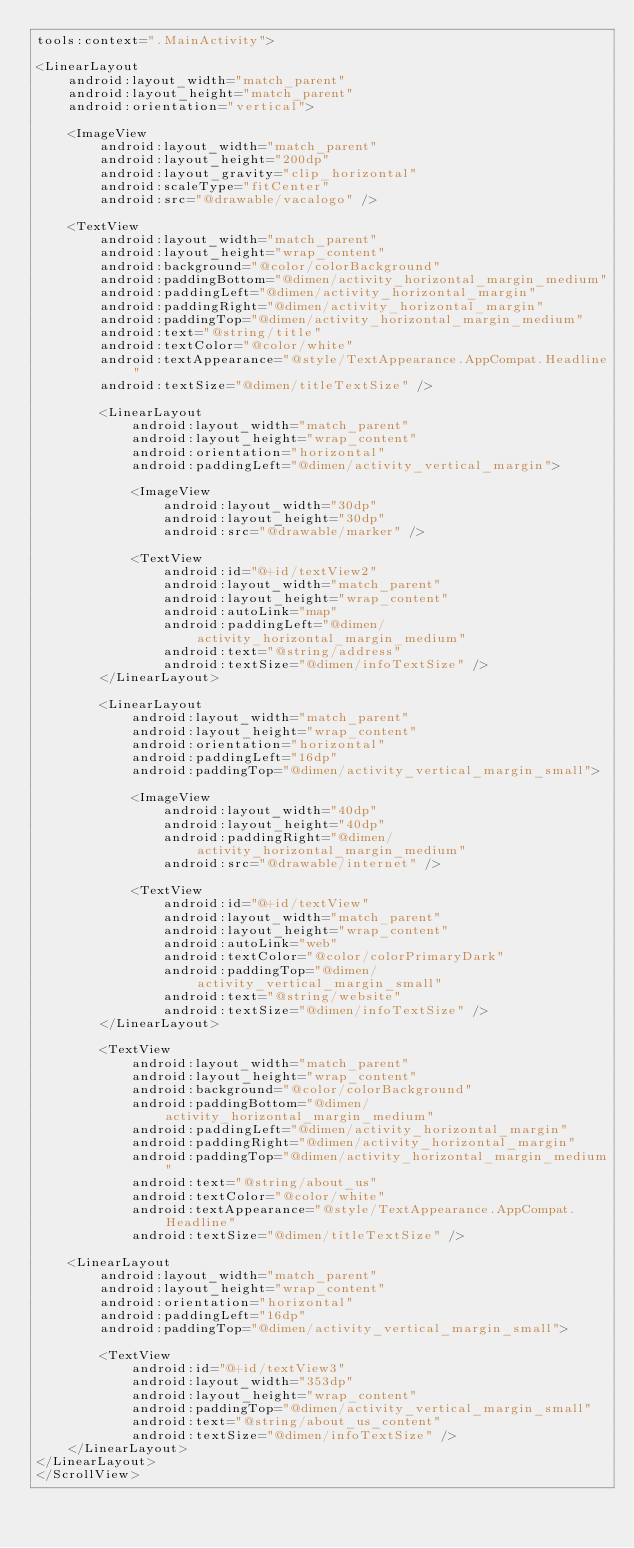<code> <loc_0><loc_0><loc_500><loc_500><_XML_>tools:context=".MainActivity">

<LinearLayout
    android:layout_width="match_parent"
    android:layout_height="match_parent"
    android:orientation="vertical">

    <ImageView
        android:layout_width="match_parent"
        android:layout_height="200dp"
        android:layout_gravity="clip_horizontal"
        android:scaleType="fitCenter"
        android:src="@drawable/vacalogo" />

    <TextView
        android:layout_width="match_parent"
        android:layout_height="wrap_content"
        android:background="@color/colorBackground"
        android:paddingBottom="@dimen/activity_horizontal_margin_medium"
        android:paddingLeft="@dimen/activity_horizontal_margin"
        android:paddingRight="@dimen/activity_horizontal_margin"
        android:paddingTop="@dimen/activity_horizontal_margin_medium"
        android:text="@string/title"
        android:textColor="@color/white"
        android:textAppearance="@style/TextAppearance.AppCompat.Headline"
        android:textSize="@dimen/titleTextSize" />

        <LinearLayout
            android:layout_width="match_parent"
            android:layout_height="wrap_content"
            android:orientation="horizontal"
            android:paddingLeft="@dimen/activity_vertical_margin">

            <ImageView
                android:layout_width="30dp"
                android:layout_height="30dp"
                android:src="@drawable/marker" />

            <TextView
                android:id="@+id/textView2"
                android:layout_width="match_parent"
                android:layout_height="wrap_content"
                android:autoLink="map"
                android:paddingLeft="@dimen/activity_horizontal_margin_medium"
                android:text="@string/address"
                android:textSize="@dimen/infoTextSize" />
        </LinearLayout>

        <LinearLayout
            android:layout_width="match_parent"
            android:layout_height="wrap_content"
            android:orientation="horizontal"
            android:paddingLeft="16dp"
            android:paddingTop="@dimen/activity_vertical_margin_small">

            <ImageView
                android:layout_width="40dp"
                android:layout_height="40dp"
                android:paddingRight="@dimen/activity_horizontal_margin_medium"
                android:src="@drawable/internet" />

            <TextView
                android:id="@+id/textView"
                android:layout_width="match_parent"
                android:layout_height="wrap_content"
                android:autoLink="web"
                android:textColor="@color/colorPrimaryDark"
                android:paddingTop="@dimen/activity_vertical_margin_small"
                android:text="@string/website"
                android:textSize="@dimen/infoTextSize" />
        </LinearLayout>

        <TextView
            android:layout_width="match_parent"
            android:layout_height="wrap_content"
            android:background="@color/colorBackground"
            android:paddingBottom="@dimen/activity_horizontal_margin_medium"
            android:paddingLeft="@dimen/activity_horizontal_margin"
            android:paddingRight="@dimen/activity_horizontal_margin"
            android:paddingTop="@dimen/activity_horizontal_margin_medium"
            android:text="@string/about_us"
            android:textColor="@color/white"
            android:textAppearance="@style/TextAppearance.AppCompat.Headline"
            android:textSize="@dimen/titleTextSize" />

    <LinearLayout
        android:layout_width="match_parent"
        android:layout_height="wrap_content"
        android:orientation="horizontal"
        android:paddingLeft="16dp"
        android:paddingTop="@dimen/activity_vertical_margin_small">

        <TextView
            android:id="@+id/textView3"
            android:layout_width="353dp"
            android:layout_height="wrap_content"
            android:paddingTop="@dimen/activity_vertical_margin_small"
            android:text="@string/about_us_content"
            android:textSize="@dimen/infoTextSize" />
    </LinearLayout>
</LinearLayout>
</ScrollView></code> 